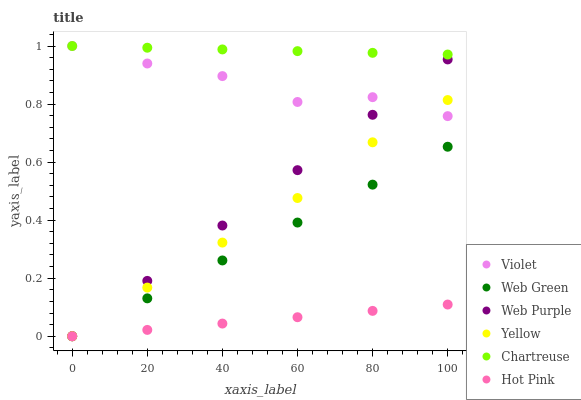Does Hot Pink have the minimum area under the curve?
Answer yes or no. Yes. Does Chartreuse have the maximum area under the curve?
Answer yes or no. Yes. Does Web Purple have the minimum area under the curve?
Answer yes or no. No. Does Web Purple have the maximum area under the curve?
Answer yes or no. No. Is Chartreuse the smoothest?
Answer yes or no. Yes. Is Violet the roughest?
Answer yes or no. Yes. Is Web Purple the smoothest?
Answer yes or no. No. Is Web Purple the roughest?
Answer yes or no. No. Does Hot Pink have the lowest value?
Answer yes or no. Yes. Does Chartreuse have the lowest value?
Answer yes or no. No. Does Violet have the highest value?
Answer yes or no. Yes. Does Web Purple have the highest value?
Answer yes or no. No. Is Web Green less than Chartreuse?
Answer yes or no. Yes. Is Chartreuse greater than Hot Pink?
Answer yes or no. Yes. Does Hot Pink intersect Web Purple?
Answer yes or no. Yes. Is Hot Pink less than Web Purple?
Answer yes or no. No. Is Hot Pink greater than Web Purple?
Answer yes or no. No. Does Web Green intersect Chartreuse?
Answer yes or no. No. 